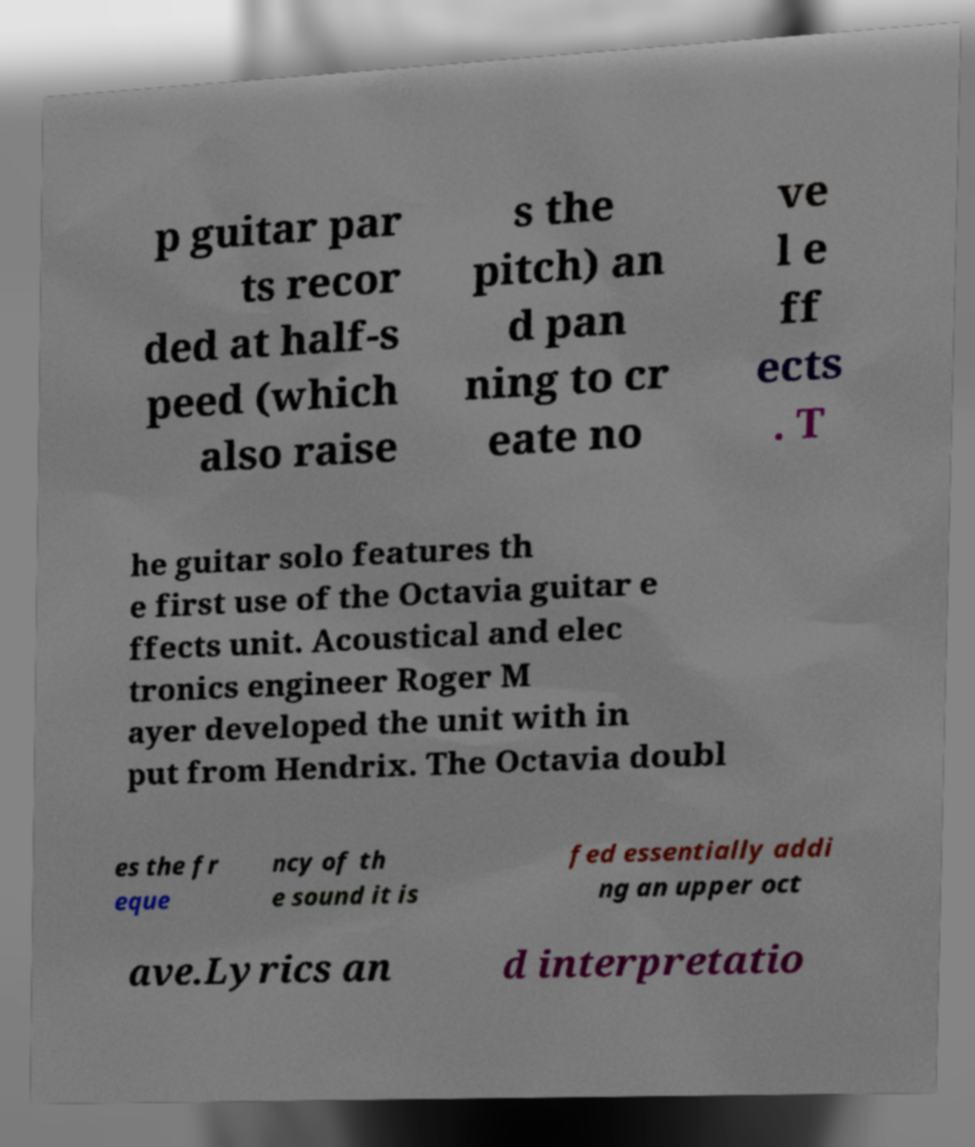I need the written content from this picture converted into text. Can you do that? p guitar par ts recor ded at half-s peed (which also raise s the pitch) an d pan ning to cr eate no ve l e ff ects . T he guitar solo features th e first use of the Octavia guitar e ffects unit. Acoustical and elec tronics engineer Roger M ayer developed the unit with in put from Hendrix. The Octavia doubl es the fr eque ncy of th e sound it is fed essentially addi ng an upper oct ave.Lyrics an d interpretatio 